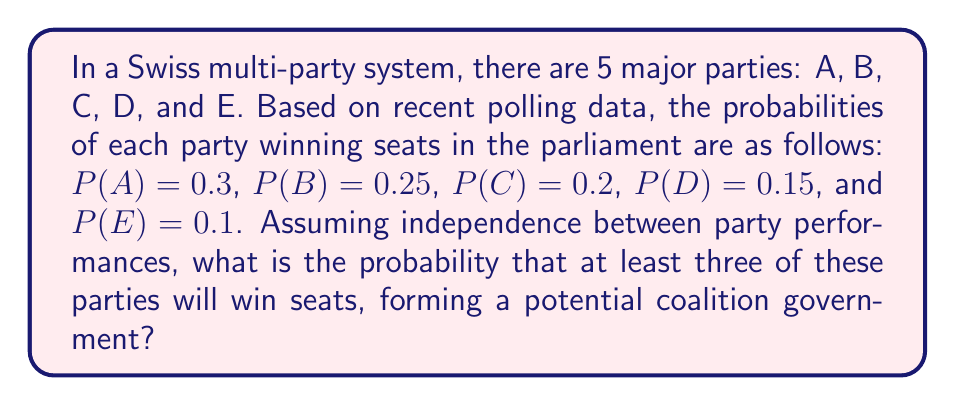What is the answer to this math problem? To solve this problem, we need to use the concept of probability of multiple events and the complementary probability principle. Let's approach this step-by-step:

1) First, let's calculate the probability of the complementary event: the probability that 2 or fewer parties win seats. This is easier than directly calculating the probability of 3 or more parties winning seats.

2) We can break this down into three cases:
   a) No party wins seats
   b) Exactly one party wins seats
   c) Exactly two parties win seats

3) Let's calculate each:

   a) Probability that no party wins seats:
      $$P(\text{no party}) = (1-0.3)(1-0.25)(1-0.2)(1-0.15)(1-0.1) = 0.7 \cdot 0.75 \cdot 0.8 \cdot 0.85 \cdot 0.9 = 0.32130$$

   b) Probability that exactly one party wins seats:
      $$P(\text{one party}) = 0.3 \cdot 0.75 \cdot 0.8 \cdot 0.85 \cdot 0.9 + 0.7 \cdot 0.25 \cdot 0.8 \cdot 0.85 \cdot 0.9 + 0.7 \cdot 0.75 \cdot 0.2 \cdot 0.85 \cdot 0.9 + 0.7 \cdot 0.75 \cdot 0.8 \cdot 0.15 \cdot 0.9 + 0.7 \cdot 0.75 \cdot 0.8 \cdot 0.85 \cdot 0.1$$
      $$= 0.13770 + 0.10710 + 0.08025 + 0.05670 + 0.03570 = 0.41745$$

   c) Probability that exactly two parties win seats:
      There are $\binom{5}{2} = 10$ ways to choose 2 parties out of 5. We need to sum the probabilities for all these combinations:
      $$P(\text{two parties}) = 0.3 \cdot 0.25 \cdot 0.8 \cdot 0.85 \cdot 0.9 + 0.3 \cdot 0.75 \cdot 0.2 \cdot 0.85 \cdot 0.9 + ... + 0.7 \cdot 0.75 \cdot 0.8 \cdot 0.85 \cdot 0.1$$
      (summing all 10 combinations)
      $$= 0.22185$$

4) The total probability of 2 or fewer parties winning seats is:
   $$P(2 \text{ or fewer}) = 0.32130 + 0.41745 + 0.22185 = 0.96060$$

5) Therefore, the probability of at least 3 parties winning seats (our desired outcome) is:
   $$P(3 \text{ or more}) = 1 - P(2 \text{ or fewer}) = 1 - 0.96060 = 0.03940$$
Answer: The probability that at least three parties will win seats, forming a potential coalition government, is approximately 0.03940 or 3.94%. 